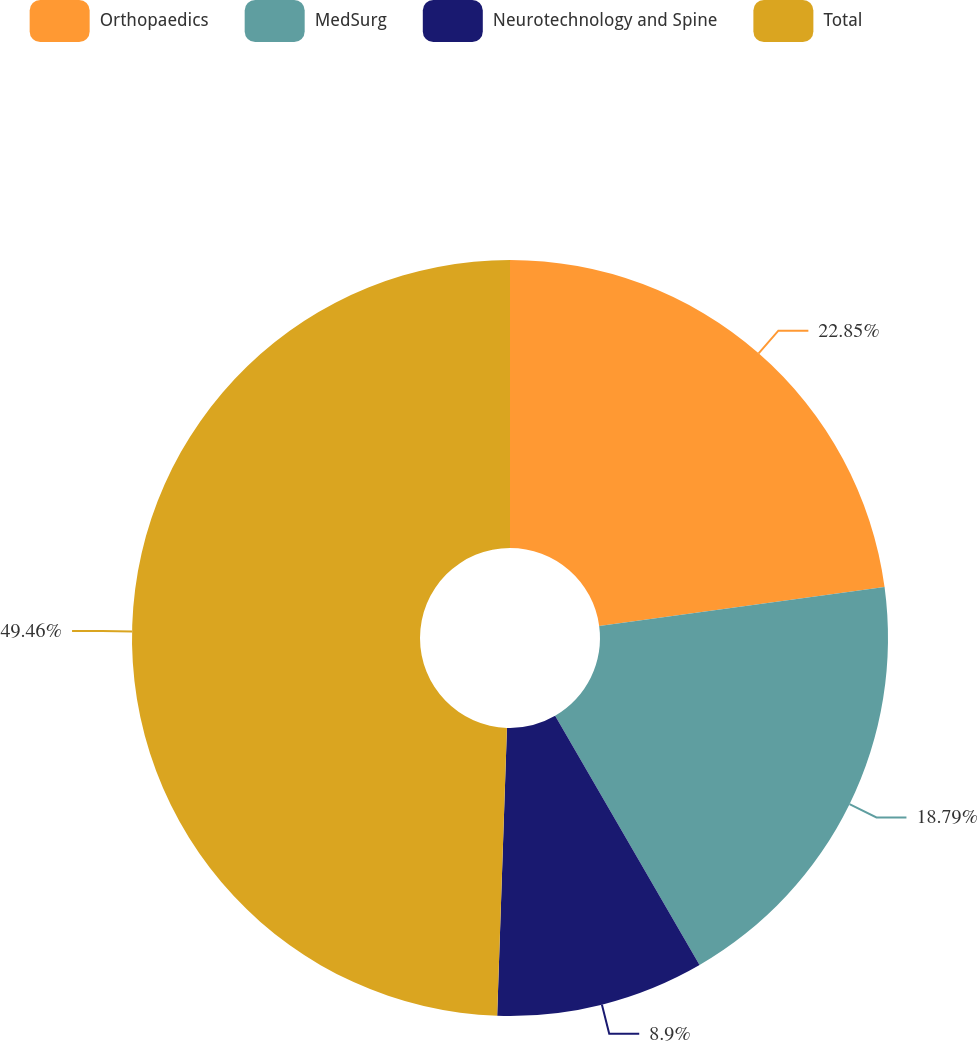<chart> <loc_0><loc_0><loc_500><loc_500><pie_chart><fcel>Orthopaedics<fcel>MedSurg<fcel>Neurotechnology and Spine<fcel>Total<nl><fcel>22.85%<fcel>18.79%<fcel>8.9%<fcel>49.46%<nl></chart> 